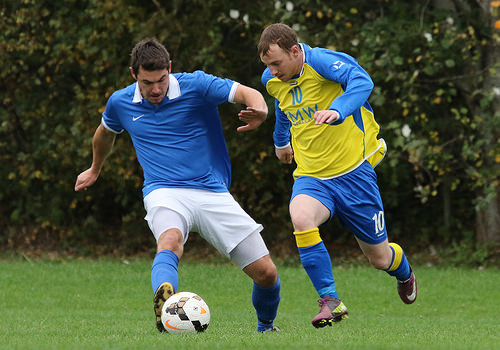<image>
Is there a ball to the left of the player? No. The ball is not to the left of the player. From this viewpoint, they have a different horizontal relationship. 